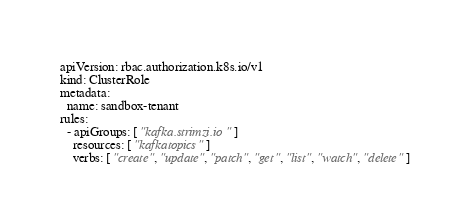Convert code to text. <code><loc_0><loc_0><loc_500><loc_500><_YAML_>apiVersion: rbac.authorization.k8s.io/v1
kind: ClusterRole
metadata:
  name: sandbox-tenant
rules:
  - apiGroups: [ "kafka.strimzi.io" ]
    resources: [ "kafkatopics" ]
    verbs: [ "create", "update", "patch", "get", "list", "watch", "delete" ]
</code> 